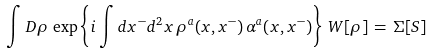<formula> <loc_0><loc_0><loc_500><loc_500>\int D \rho \, \exp \left \{ i \int d x ^ { - } d ^ { 2 } x \, \rho ^ { a } ( x , x ^ { - } ) \, \alpha ^ { a } ( x , x ^ { - } ) \right \} \, W [ \rho ] \, = \, \Sigma [ S ]</formula> 